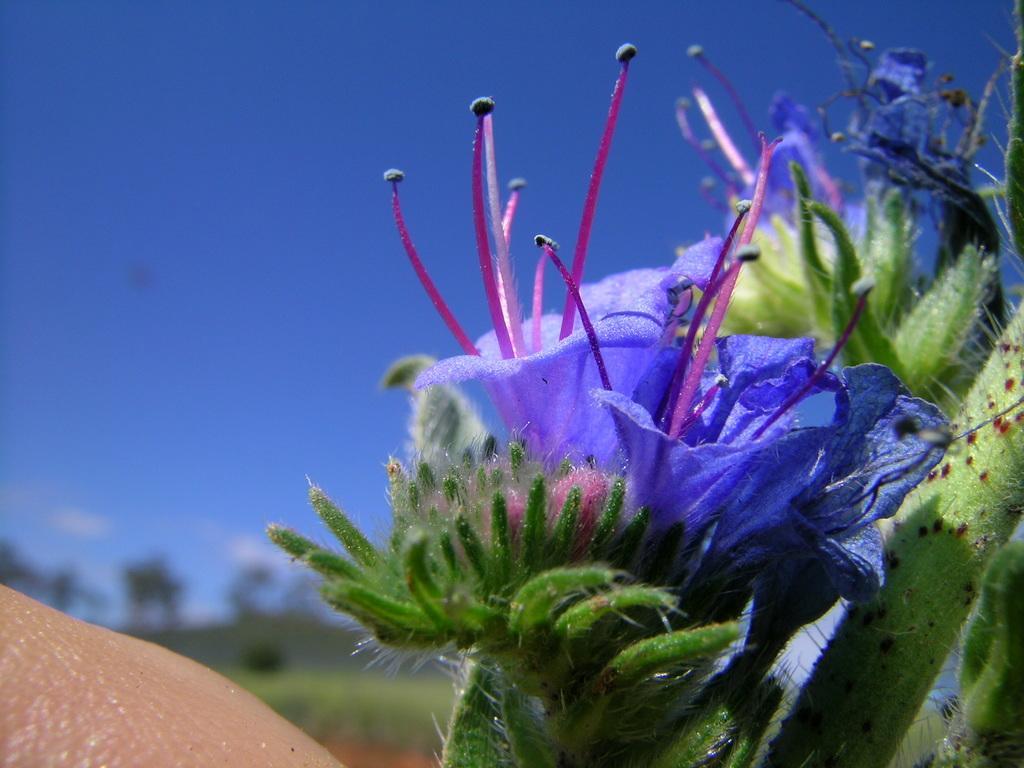In one or two sentences, can you explain what this image depicts? In this image we can see blue color flowers. The background of the image is slightly blurred, where we can see trees and the blue color sky. 